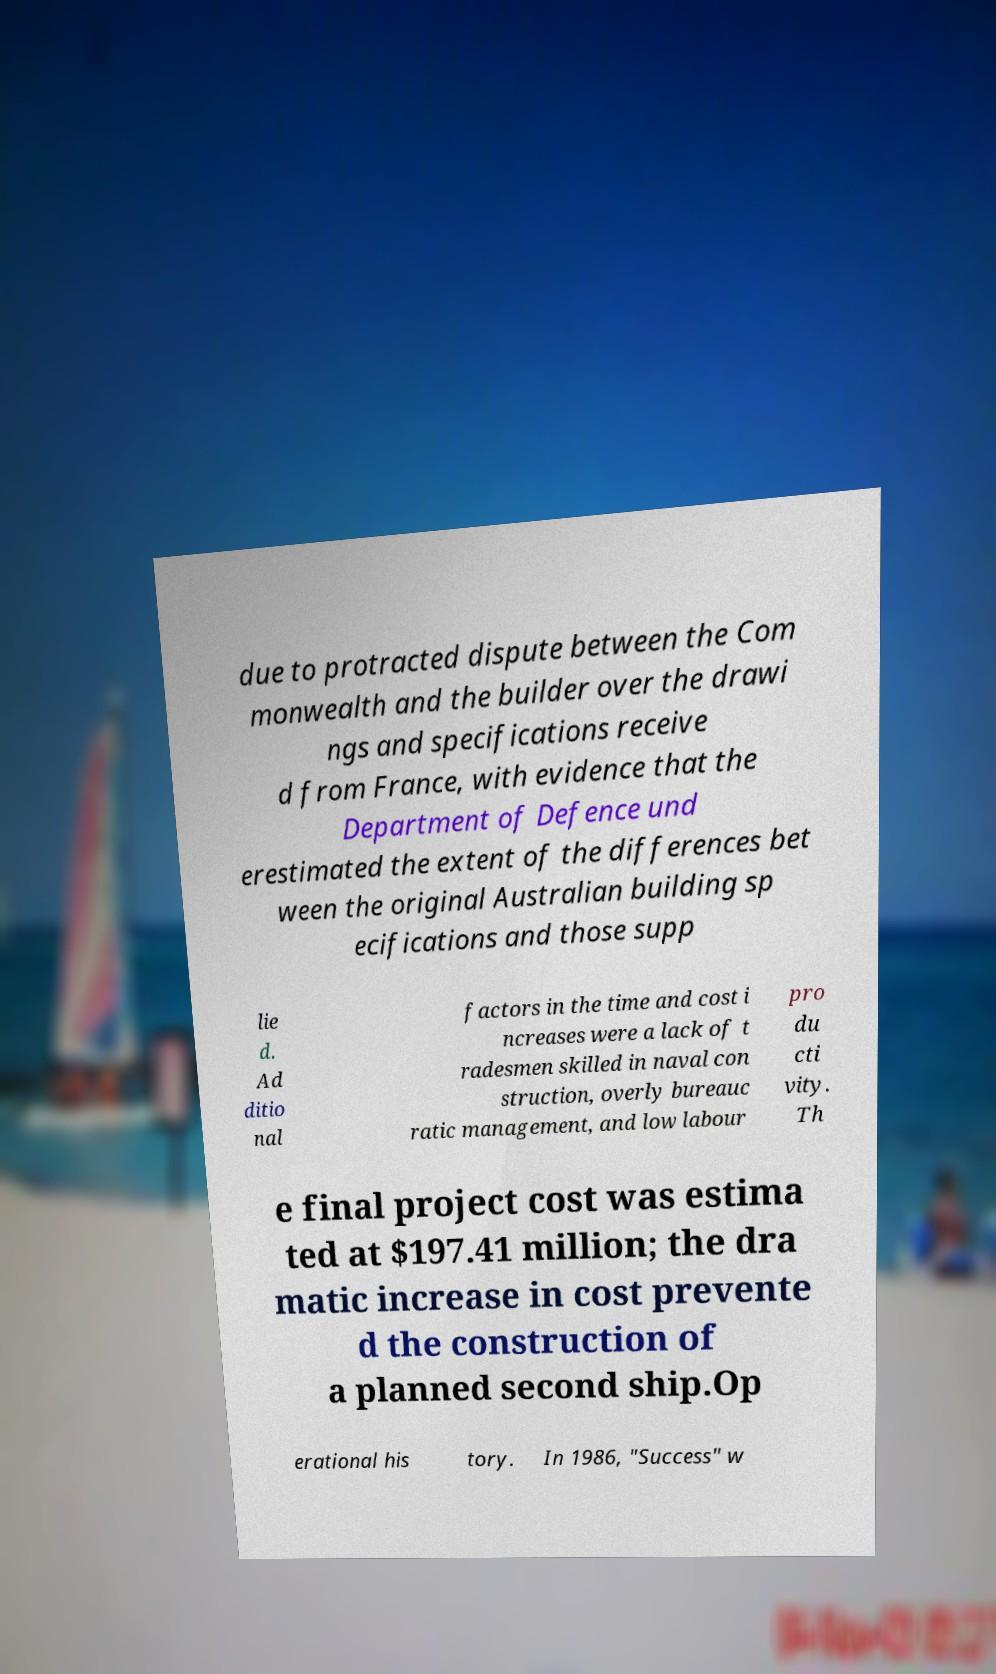There's text embedded in this image that I need extracted. Can you transcribe it verbatim? due to protracted dispute between the Com monwealth and the builder over the drawi ngs and specifications receive d from France, with evidence that the Department of Defence und erestimated the extent of the differences bet ween the original Australian building sp ecifications and those supp lie d. Ad ditio nal factors in the time and cost i ncreases were a lack of t radesmen skilled in naval con struction, overly bureauc ratic management, and low labour pro du cti vity. Th e final project cost was estima ted at $197.41 million; the dra matic increase in cost prevente d the construction of a planned second ship.Op erational his tory. In 1986, "Success" w 